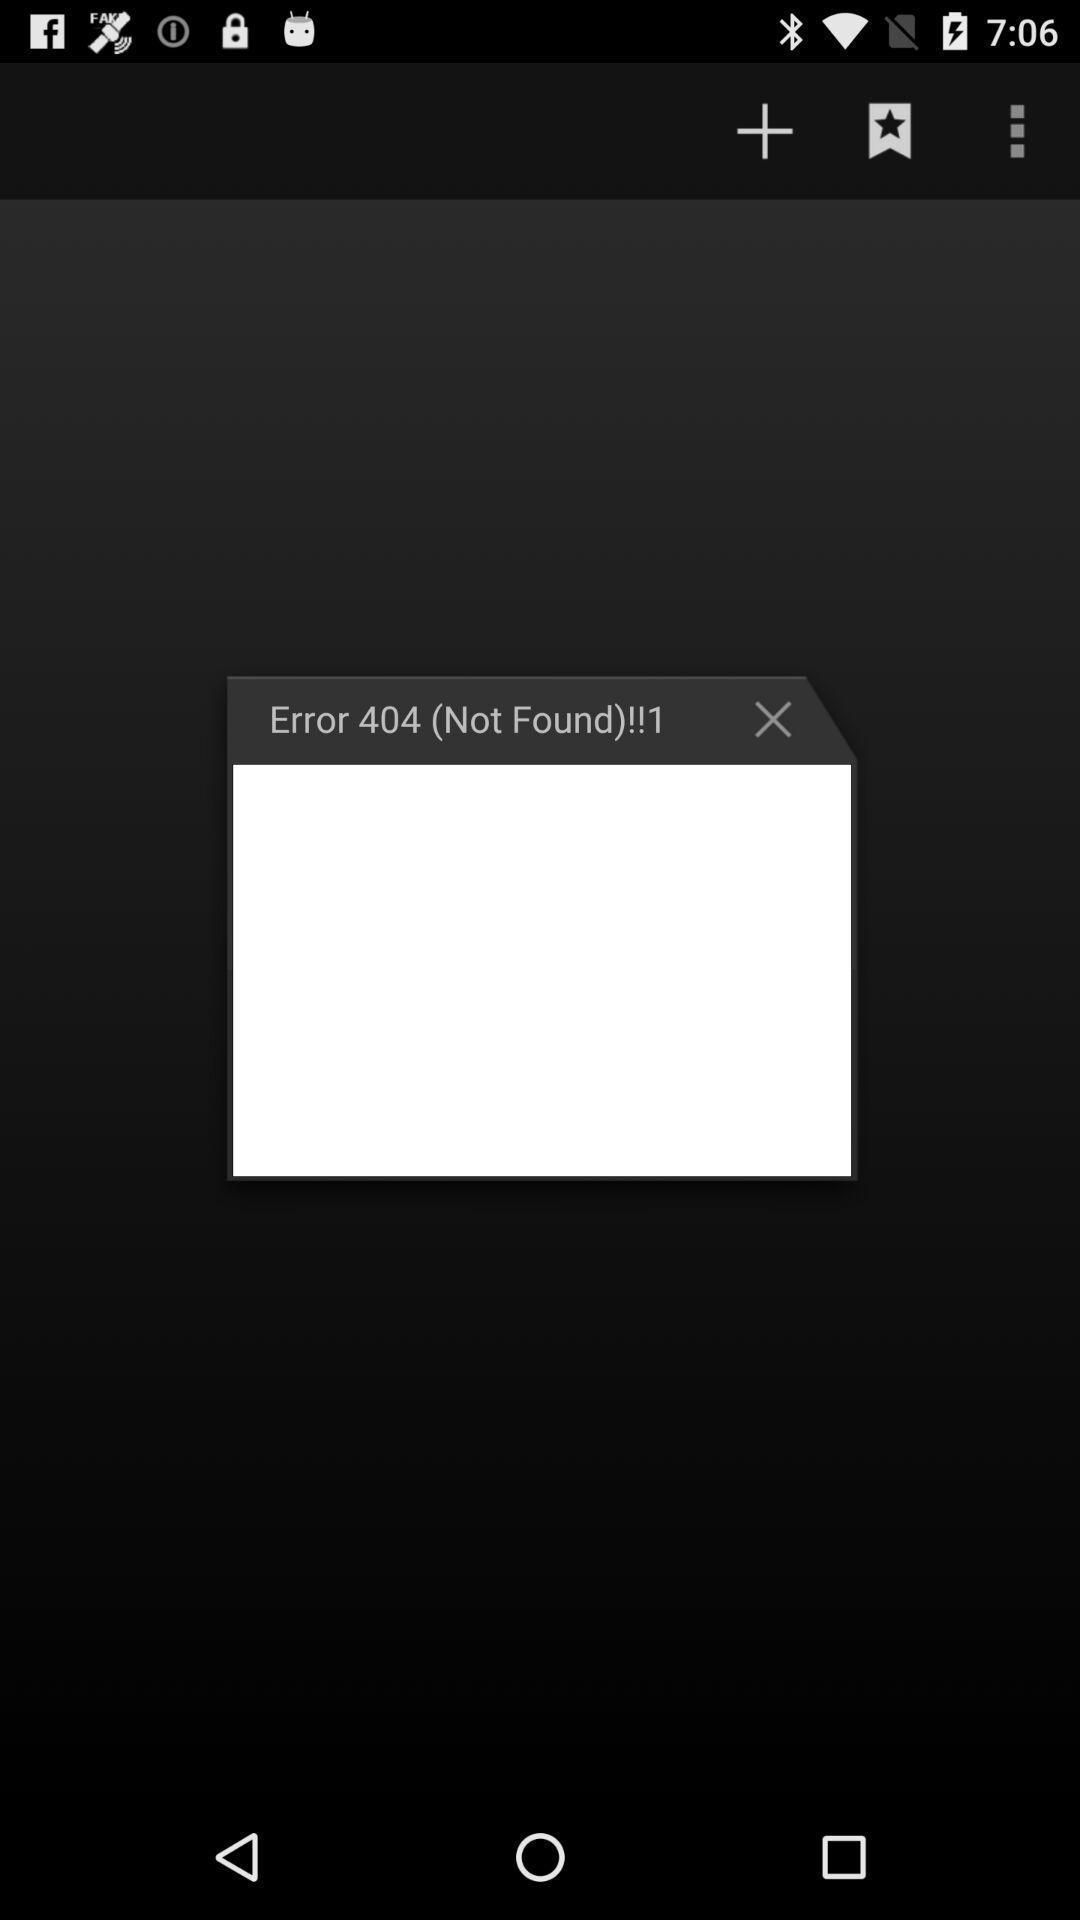Explain the elements present in this screenshot. Screen displaying error 404 message. 